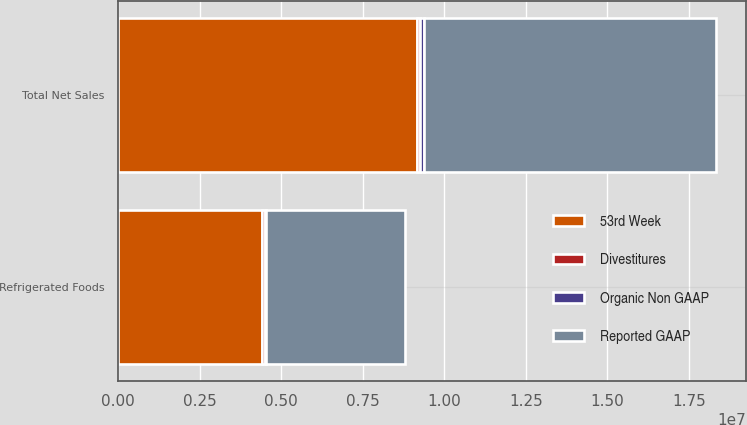Convert chart to OTSL. <chart><loc_0><loc_0><loc_500><loc_500><stacked_bar_chart><ecel><fcel>Refrigerated Foods<fcel>Total Net Sales<nl><fcel>53rd Week<fcel>4.40373e+06<fcel>9.16752e+06<nl><fcel>Organic Non GAAP<fcel>44450<fcel>96748<nl><fcel>Divestitures<fcel>100231<fcel>100231<nl><fcel>Reported GAAP<fcel>4.25905e+06<fcel>8.97054e+06<nl></chart> 